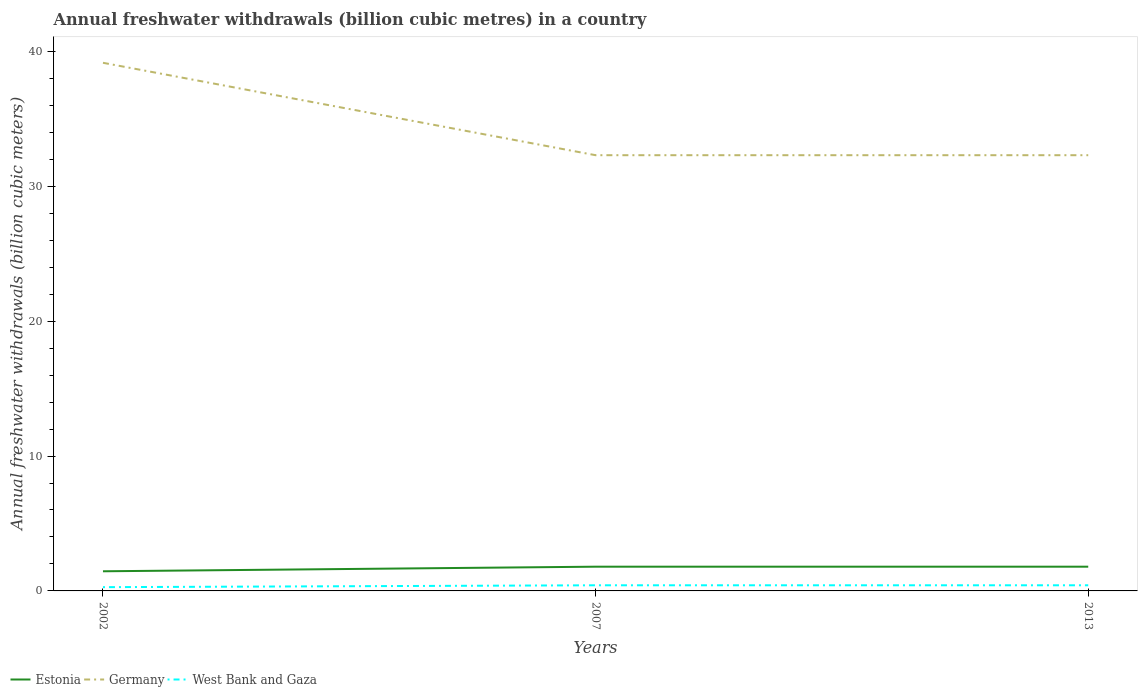Does the line corresponding to Germany intersect with the line corresponding to West Bank and Gaza?
Offer a very short reply. No. Is the number of lines equal to the number of legend labels?
Keep it short and to the point. Yes. Across all years, what is the maximum annual freshwater withdrawals in Estonia?
Offer a terse response. 1.46. In which year was the annual freshwater withdrawals in West Bank and Gaza maximum?
Ensure brevity in your answer.  2002. What is the total annual freshwater withdrawals in West Bank and Gaza in the graph?
Provide a succinct answer. 0. What is the difference between the highest and the second highest annual freshwater withdrawals in Germany?
Make the answer very short. 6.85. What is the difference between the highest and the lowest annual freshwater withdrawals in West Bank and Gaza?
Offer a very short reply. 2. Is the annual freshwater withdrawals in Germany strictly greater than the annual freshwater withdrawals in Estonia over the years?
Keep it short and to the point. No. How many lines are there?
Make the answer very short. 3. What is the difference between two consecutive major ticks on the Y-axis?
Provide a short and direct response. 10. Does the graph contain any zero values?
Provide a short and direct response. No. Does the graph contain grids?
Ensure brevity in your answer.  No. Where does the legend appear in the graph?
Your response must be concise. Bottom left. How many legend labels are there?
Keep it short and to the point. 3. What is the title of the graph?
Give a very brief answer. Annual freshwater withdrawals (billion cubic metres) in a country. Does "Uruguay" appear as one of the legend labels in the graph?
Ensure brevity in your answer.  No. What is the label or title of the Y-axis?
Your answer should be very brief. Annual freshwater withdrawals (billion cubic meters). What is the Annual freshwater withdrawals (billion cubic meters) of Estonia in 2002?
Your answer should be very brief. 1.46. What is the Annual freshwater withdrawals (billion cubic meters) of Germany in 2002?
Offer a terse response. 39.15. What is the Annual freshwater withdrawals (billion cubic meters) of West Bank and Gaza in 2002?
Give a very brief answer. 0.28. What is the Annual freshwater withdrawals (billion cubic meters) in Estonia in 2007?
Offer a terse response. 1.8. What is the Annual freshwater withdrawals (billion cubic meters) in Germany in 2007?
Provide a succinct answer. 32.3. What is the Annual freshwater withdrawals (billion cubic meters) in West Bank and Gaza in 2007?
Your answer should be compact. 0.42. What is the Annual freshwater withdrawals (billion cubic meters) of Estonia in 2013?
Ensure brevity in your answer.  1.8. What is the Annual freshwater withdrawals (billion cubic meters) in Germany in 2013?
Your answer should be compact. 32.3. What is the Annual freshwater withdrawals (billion cubic meters) of West Bank and Gaza in 2013?
Give a very brief answer. 0.42. Across all years, what is the maximum Annual freshwater withdrawals (billion cubic meters) of Estonia?
Keep it short and to the point. 1.8. Across all years, what is the maximum Annual freshwater withdrawals (billion cubic meters) of Germany?
Provide a succinct answer. 39.15. Across all years, what is the maximum Annual freshwater withdrawals (billion cubic meters) in West Bank and Gaza?
Give a very brief answer. 0.42. Across all years, what is the minimum Annual freshwater withdrawals (billion cubic meters) in Estonia?
Offer a terse response. 1.46. Across all years, what is the minimum Annual freshwater withdrawals (billion cubic meters) in Germany?
Make the answer very short. 32.3. Across all years, what is the minimum Annual freshwater withdrawals (billion cubic meters) in West Bank and Gaza?
Your response must be concise. 0.28. What is the total Annual freshwater withdrawals (billion cubic meters) in Estonia in the graph?
Your response must be concise. 5.05. What is the total Annual freshwater withdrawals (billion cubic meters) of Germany in the graph?
Offer a very short reply. 103.75. What is the total Annual freshwater withdrawals (billion cubic meters) in West Bank and Gaza in the graph?
Make the answer very short. 1.11. What is the difference between the Annual freshwater withdrawals (billion cubic meters) of Estonia in 2002 and that in 2007?
Give a very brief answer. -0.34. What is the difference between the Annual freshwater withdrawals (billion cubic meters) of Germany in 2002 and that in 2007?
Offer a very short reply. 6.85. What is the difference between the Annual freshwater withdrawals (billion cubic meters) in West Bank and Gaza in 2002 and that in 2007?
Your answer should be very brief. -0.14. What is the difference between the Annual freshwater withdrawals (billion cubic meters) of Estonia in 2002 and that in 2013?
Your answer should be very brief. -0.34. What is the difference between the Annual freshwater withdrawals (billion cubic meters) of Germany in 2002 and that in 2013?
Your response must be concise. 6.85. What is the difference between the Annual freshwater withdrawals (billion cubic meters) of West Bank and Gaza in 2002 and that in 2013?
Your answer should be very brief. -0.14. What is the difference between the Annual freshwater withdrawals (billion cubic meters) of Estonia in 2007 and that in 2013?
Keep it short and to the point. 0. What is the difference between the Annual freshwater withdrawals (billion cubic meters) of West Bank and Gaza in 2007 and that in 2013?
Your answer should be very brief. 0. What is the difference between the Annual freshwater withdrawals (billion cubic meters) of Estonia in 2002 and the Annual freshwater withdrawals (billion cubic meters) of Germany in 2007?
Give a very brief answer. -30.84. What is the difference between the Annual freshwater withdrawals (billion cubic meters) in Estonia in 2002 and the Annual freshwater withdrawals (billion cubic meters) in West Bank and Gaza in 2007?
Make the answer very short. 1.04. What is the difference between the Annual freshwater withdrawals (billion cubic meters) in Germany in 2002 and the Annual freshwater withdrawals (billion cubic meters) in West Bank and Gaza in 2007?
Make the answer very short. 38.73. What is the difference between the Annual freshwater withdrawals (billion cubic meters) of Estonia in 2002 and the Annual freshwater withdrawals (billion cubic meters) of Germany in 2013?
Make the answer very short. -30.84. What is the difference between the Annual freshwater withdrawals (billion cubic meters) in Estonia in 2002 and the Annual freshwater withdrawals (billion cubic meters) in West Bank and Gaza in 2013?
Your answer should be very brief. 1.04. What is the difference between the Annual freshwater withdrawals (billion cubic meters) of Germany in 2002 and the Annual freshwater withdrawals (billion cubic meters) of West Bank and Gaza in 2013?
Your answer should be very brief. 38.73. What is the difference between the Annual freshwater withdrawals (billion cubic meters) in Estonia in 2007 and the Annual freshwater withdrawals (billion cubic meters) in Germany in 2013?
Make the answer very short. -30.5. What is the difference between the Annual freshwater withdrawals (billion cubic meters) of Estonia in 2007 and the Annual freshwater withdrawals (billion cubic meters) of West Bank and Gaza in 2013?
Keep it short and to the point. 1.38. What is the difference between the Annual freshwater withdrawals (billion cubic meters) in Germany in 2007 and the Annual freshwater withdrawals (billion cubic meters) in West Bank and Gaza in 2013?
Offer a terse response. 31.88. What is the average Annual freshwater withdrawals (billion cubic meters) of Estonia per year?
Make the answer very short. 1.68. What is the average Annual freshwater withdrawals (billion cubic meters) of Germany per year?
Offer a very short reply. 34.58. What is the average Annual freshwater withdrawals (billion cubic meters) of West Bank and Gaza per year?
Your answer should be very brief. 0.37. In the year 2002, what is the difference between the Annual freshwater withdrawals (billion cubic meters) in Estonia and Annual freshwater withdrawals (billion cubic meters) in Germany?
Offer a very short reply. -37.69. In the year 2002, what is the difference between the Annual freshwater withdrawals (billion cubic meters) in Estonia and Annual freshwater withdrawals (billion cubic meters) in West Bank and Gaza?
Give a very brief answer. 1.18. In the year 2002, what is the difference between the Annual freshwater withdrawals (billion cubic meters) in Germany and Annual freshwater withdrawals (billion cubic meters) in West Bank and Gaza?
Make the answer very short. 38.87. In the year 2007, what is the difference between the Annual freshwater withdrawals (billion cubic meters) of Estonia and Annual freshwater withdrawals (billion cubic meters) of Germany?
Provide a succinct answer. -30.5. In the year 2007, what is the difference between the Annual freshwater withdrawals (billion cubic meters) in Estonia and Annual freshwater withdrawals (billion cubic meters) in West Bank and Gaza?
Make the answer very short. 1.38. In the year 2007, what is the difference between the Annual freshwater withdrawals (billion cubic meters) in Germany and Annual freshwater withdrawals (billion cubic meters) in West Bank and Gaza?
Your answer should be compact. 31.88. In the year 2013, what is the difference between the Annual freshwater withdrawals (billion cubic meters) in Estonia and Annual freshwater withdrawals (billion cubic meters) in Germany?
Provide a succinct answer. -30.5. In the year 2013, what is the difference between the Annual freshwater withdrawals (billion cubic meters) of Estonia and Annual freshwater withdrawals (billion cubic meters) of West Bank and Gaza?
Offer a very short reply. 1.38. In the year 2013, what is the difference between the Annual freshwater withdrawals (billion cubic meters) in Germany and Annual freshwater withdrawals (billion cubic meters) in West Bank and Gaza?
Your answer should be very brief. 31.88. What is the ratio of the Annual freshwater withdrawals (billion cubic meters) in Estonia in 2002 to that in 2007?
Provide a succinct answer. 0.81. What is the ratio of the Annual freshwater withdrawals (billion cubic meters) in Germany in 2002 to that in 2007?
Your answer should be compact. 1.21. What is the ratio of the Annual freshwater withdrawals (billion cubic meters) in West Bank and Gaza in 2002 to that in 2007?
Ensure brevity in your answer.  0.67. What is the ratio of the Annual freshwater withdrawals (billion cubic meters) of Estonia in 2002 to that in 2013?
Ensure brevity in your answer.  0.81. What is the ratio of the Annual freshwater withdrawals (billion cubic meters) of Germany in 2002 to that in 2013?
Keep it short and to the point. 1.21. What is the ratio of the Annual freshwater withdrawals (billion cubic meters) in West Bank and Gaza in 2002 to that in 2013?
Provide a short and direct response. 0.67. What is the difference between the highest and the second highest Annual freshwater withdrawals (billion cubic meters) of Germany?
Give a very brief answer. 6.85. What is the difference between the highest and the lowest Annual freshwater withdrawals (billion cubic meters) in Estonia?
Provide a succinct answer. 0.34. What is the difference between the highest and the lowest Annual freshwater withdrawals (billion cubic meters) in Germany?
Provide a succinct answer. 6.85. What is the difference between the highest and the lowest Annual freshwater withdrawals (billion cubic meters) in West Bank and Gaza?
Offer a terse response. 0.14. 